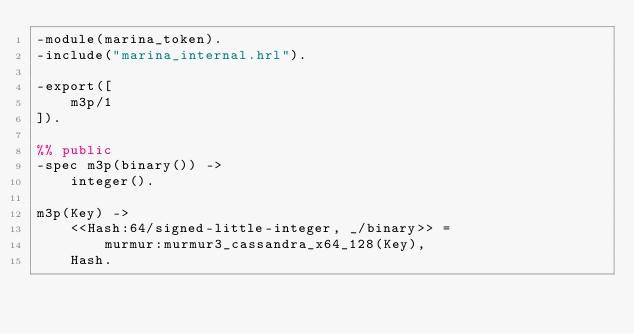<code> <loc_0><loc_0><loc_500><loc_500><_Erlang_>-module(marina_token).
-include("marina_internal.hrl").

-export([
    m3p/1
]).

%% public
-spec m3p(binary()) ->
    integer().

m3p(Key) ->
    <<Hash:64/signed-little-integer, _/binary>> =
        murmur:murmur3_cassandra_x64_128(Key),
    Hash.
</code> 